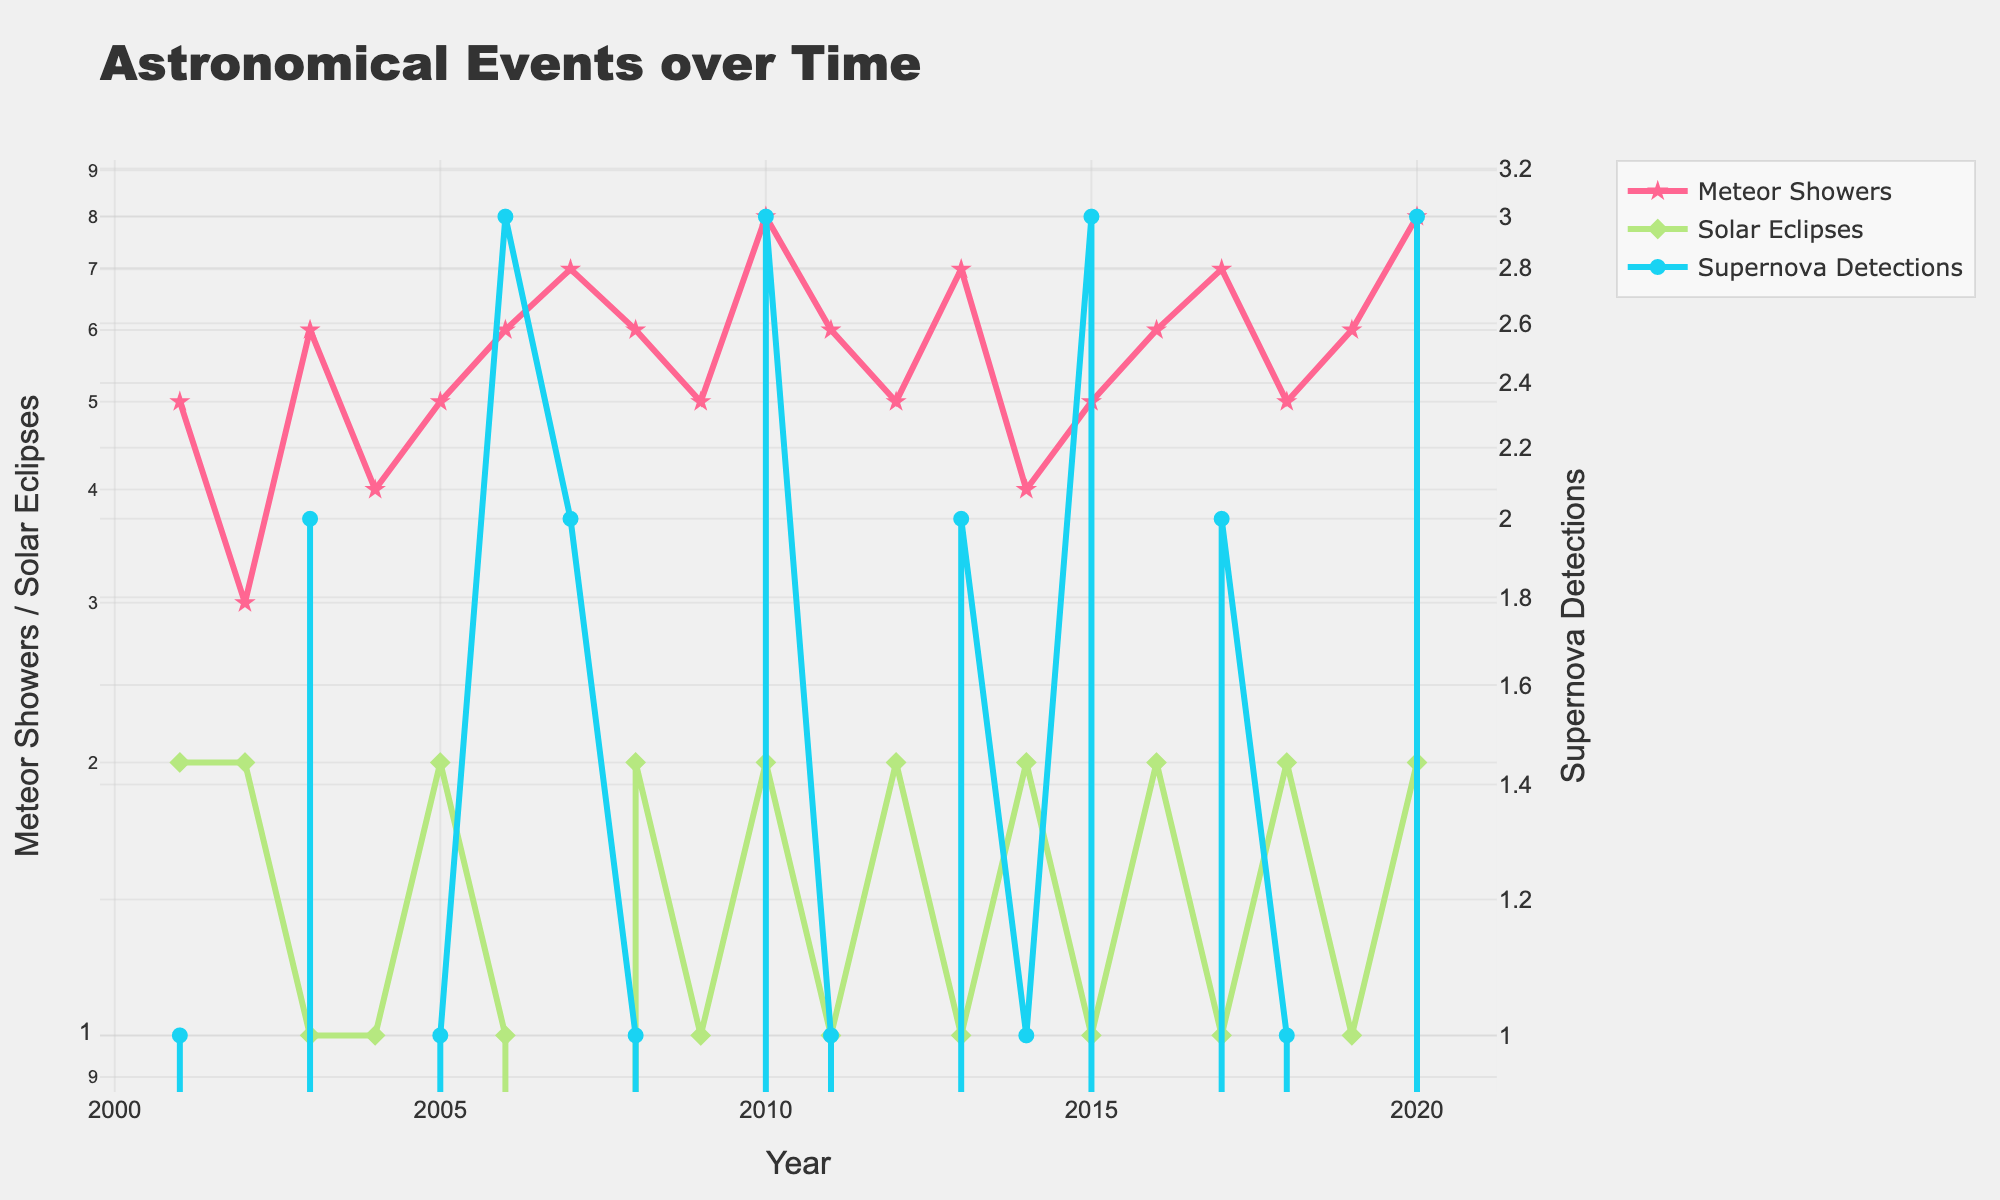What's the title of the figure? The title of the figure is typically located at the top and it summarizes the content of the graph. Here, the title text reads "Astronomical Events over Time".
Answer: Astronomical Events over Time What is the y-axis title for Meteor Showers and Solar Eclipses? The y-axis title can usually be found on the left side of the plot. In this figure, the left y-axis title reads "Meteor Showers / Solar Eclipses".
Answer: Meteor Showers / Solar Eclipses Which year had the highest number of supernova detections? To find the year with the highest number of supernova detections, look at the blue line representing supernova detections on the right y-axis and identify the highest point. The year corresponding to this point is 2010 and 2020 with 3 supernova detections each.
Answer: 2010, 2020 What was the total number of solar eclipses from 2001 to 2020? To determine the total number of solar eclipses, you sum the number of solar eclipses for all years. Summing them, you get 2+2+1+1+2+1+0+2+1+2+1+2+1+2+1+2+1+2+1+2 = 30.
Answer: 30 Are there any years with more than 6 meteor showers? If so, which? To find years with more than 6 meteor showers, examine the pink line. The years with values greater than 6 are 2007, 2010, 2013, 2017, and 2020.
Answer: 2007, 2010, 2013, 2017, 2020 Which year had both the lowest number of meteor showers and the highest number of solar eclipses? For meteor showers, find the lowest point on the pink line, which corresponds to multiple years. Then find the highest point on the green line for solar eclipses. Here, no single year fulfills both criteria simultaneously.
Answer: None How many years have exactly 2 supernova detections? Locate the blue line on the right y-axis and count the years where the value is exactly 2. These years are 2003, 2007, 2013, 2017, and 2018.
Answer: 5 What is the average number of meteor showers from 2010 to 2015? Sum the meteor showers from 2010 to 2015: 8+6+5+7+4+5 = 35. Divide by the number of years (6) to find the average: 35/6 ≈ 5.83.
Answer: 5.83 In which year did the number of meteor showers surpass the number of solar eclipses by the largest margin? Subtract the number of solar eclipses from meteor showers for each year and find the year with the largest positive difference. The largest margin is 8 (meteor showers) - 0 (solar eclipses) in 2020, so the margin is 8 in 2020.
Answer: 2020 Do the supernova detections show a trend correlated with the number of meteor showers or solar eclipses? Observing the lines for trends, we see no clear correlation between supernova detections (blue line) and the other two types of events (pink and green lines), as they largely vary independently.
Answer: No 